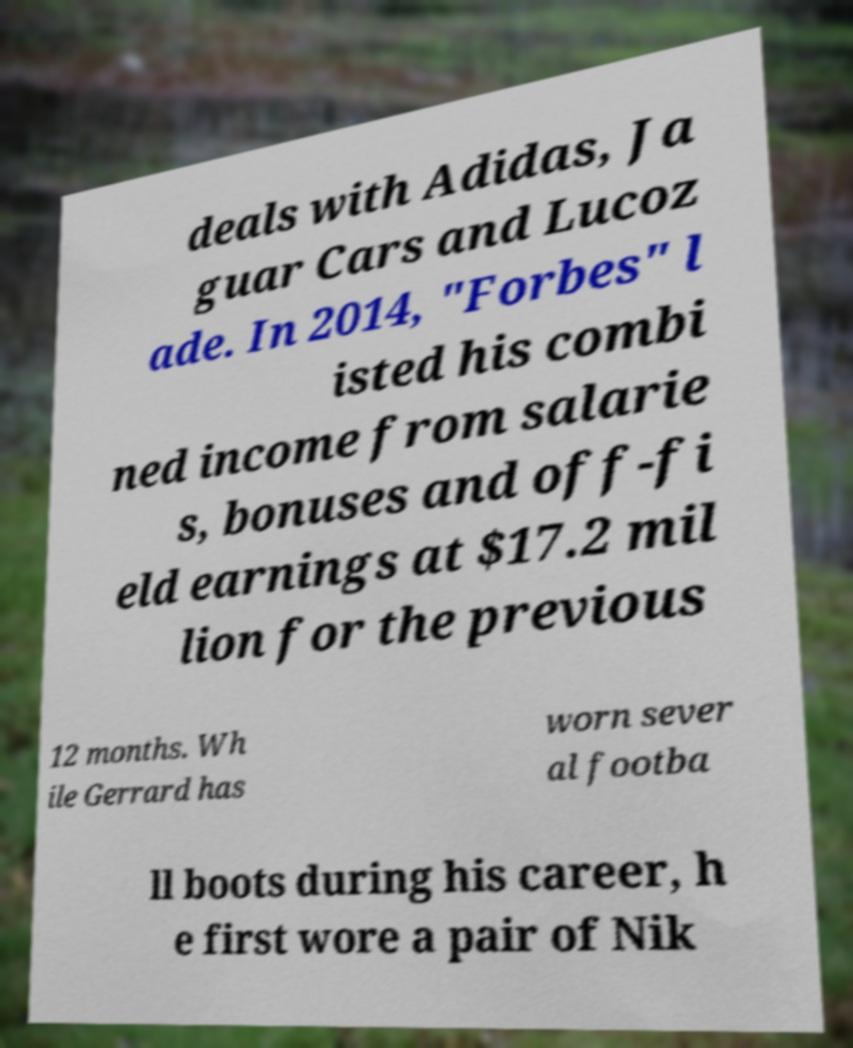Could you assist in decoding the text presented in this image and type it out clearly? deals with Adidas, Ja guar Cars and Lucoz ade. In 2014, "Forbes" l isted his combi ned income from salarie s, bonuses and off-fi eld earnings at $17.2 mil lion for the previous 12 months. Wh ile Gerrard has worn sever al footba ll boots during his career, h e first wore a pair of Nik 